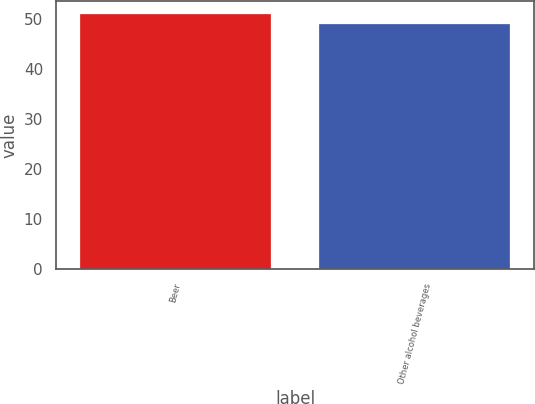<chart> <loc_0><loc_0><loc_500><loc_500><bar_chart><fcel>Beer<fcel>Other alcohol beverages<nl><fcel>51<fcel>49<nl></chart> 